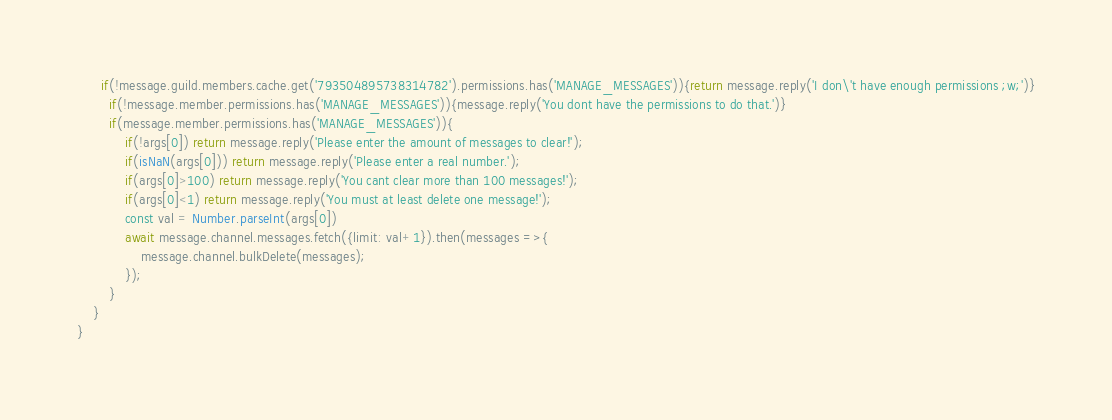<code> <loc_0><loc_0><loc_500><loc_500><_JavaScript_>      if(!message.guild.members.cache.get('793504895738314782').permissions.has('MANAGE_MESSAGES')){return message.reply('I don\'t have enough permissions ;w;')}
        if(!message.member.permissions.has('MANAGE_MESSAGES')){message.reply('You dont have the permissions to do that.')}
        if(message.member.permissions.has('MANAGE_MESSAGES')){
            if(!args[0]) return message.reply('Please enter the amount of messages to clear!');
            if(isNaN(args[0])) return message.reply('Please enter a real number.');
            if(args[0]>100) return message.reply('You cant clear more than 100 messages!');
            if(args[0]<1) return message.reply('You must at least delete one message!');
            const val = Number.parseInt(args[0])
            await message.channel.messages.fetch({limit: val+1}).then(messages =>{
                message.channel.bulkDelete(messages);
            });
        }
    }
}</code> 